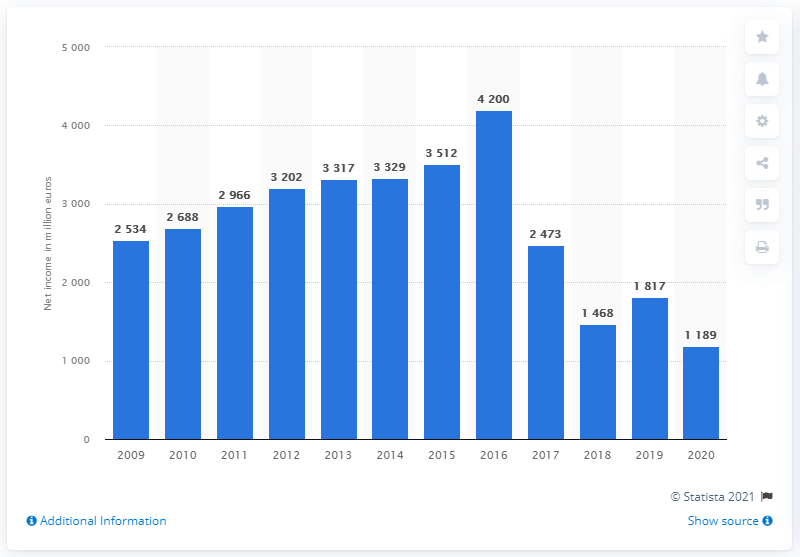Give some essential details in this illustration. IKEA's global net income in 2020 was 1189 million U.S. dollars. In 2016, IKEA's net income was 4,200. 